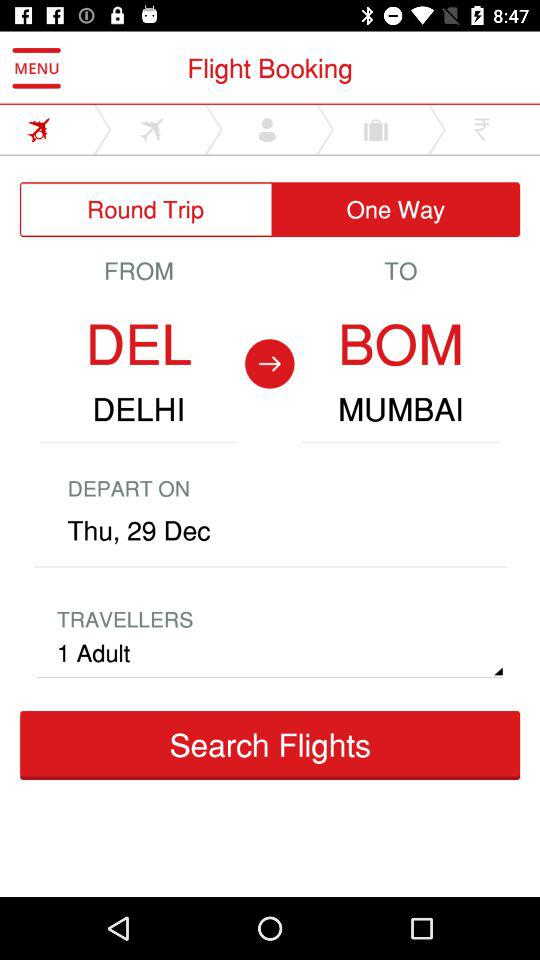For what date is the flight booking process in progress? The date is Thursday, December 29. 